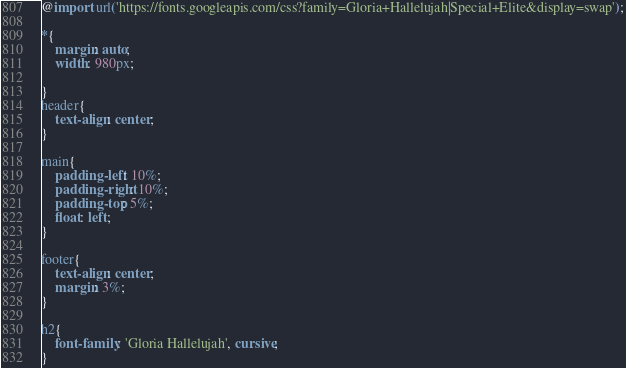<code> <loc_0><loc_0><loc_500><loc_500><_CSS_>@import url('https://fonts.googleapis.com/css?family=Gloria+Hallelujah|Special+Elite&display=swap');

*{
    margin: auto;
    width: 980px;
    
}
header{
    text-align: center;
}

main{
    padding-left: 10%;
    padding-right: 10%;
    padding-top: 5%;
    float: left;
}

footer{
    text-align: center;
    margin: 3%;
}

h2{
    font-family: 'Gloria Hallelujah', cursive;
}</code> 